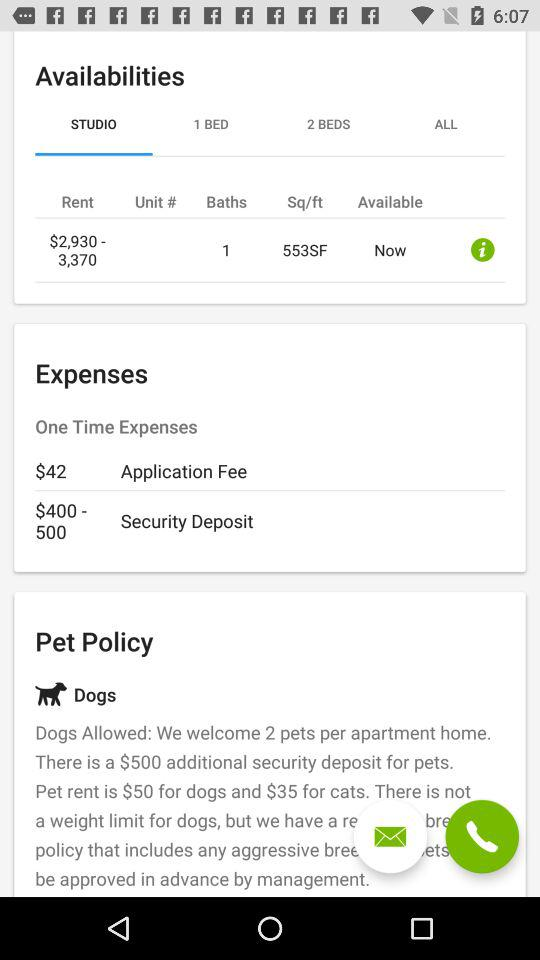What is the application fee? The application fee is $42. 